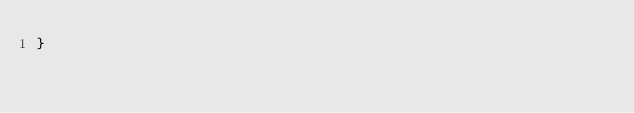<code> <loc_0><loc_0><loc_500><loc_500><_Go_>}
</code> 